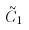Convert formula to latex. <formula><loc_0><loc_0><loc_500><loc_500>\tilde { C } _ { 1 }</formula> 